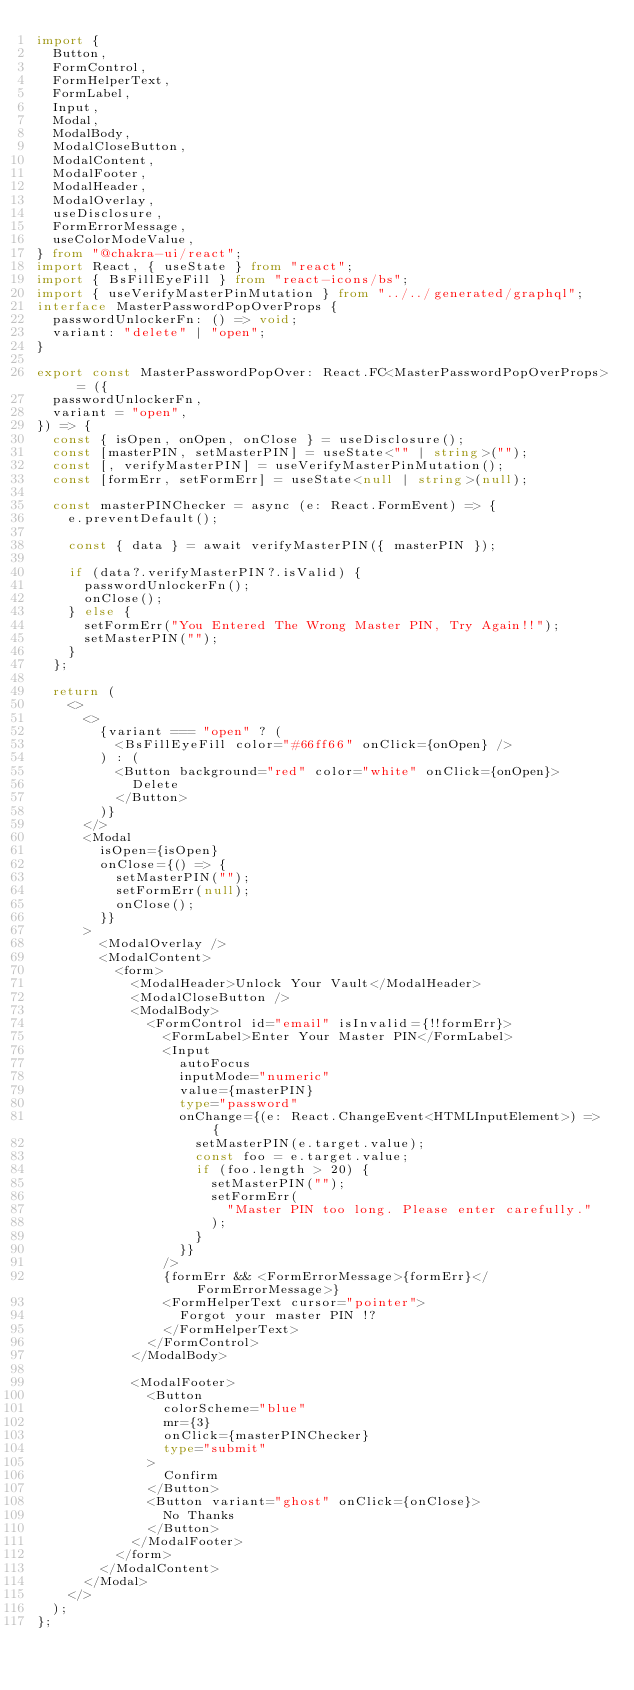Convert code to text. <code><loc_0><loc_0><loc_500><loc_500><_TypeScript_>import {
  Button,
  FormControl,
  FormHelperText,
  FormLabel,
  Input,
  Modal,
  ModalBody,
  ModalCloseButton,
  ModalContent,
  ModalFooter,
  ModalHeader,
  ModalOverlay,
  useDisclosure,
  FormErrorMessage,
  useColorModeValue,
} from "@chakra-ui/react";
import React, { useState } from "react";
import { BsFillEyeFill } from "react-icons/bs";
import { useVerifyMasterPinMutation } from "../../generated/graphql";
interface MasterPasswordPopOverProps {
  passwordUnlockerFn: () => void;
  variant: "delete" | "open";
}

export const MasterPasswordPopOver: React.FC<MasterPasswordPopOverProps> = ({
  passwordUnlockerFn,
  variant = "open",
}) => {
  const { isOpen, onOpen, onClose } = useDisclosure();
  const [masterPIN, setMasterPIN] = useState<"" | string>("");
  const [, verifyMasterPIN] = useVerifyMasterPinMutation();
  const [formErr, setFormErr] = useState<null | string>(null);

  const masterPINChecker = async (e: React.FormEvent) => {
    e.preventDefault();

    const { data } = await verifyMasterPIN({ masterPIN });

    if (data?.verifyMasterPIN?.isValid) {
      passwordUnlockerFn();
      onClose();
    } else {
      setFormErr("You Entered The Wrong Master PIN, Try Again!!");
      setMasterPIN("");
    }
  };

  return (
    <>
      <>
        {variant === "open" ? (
          <BsFillEyeFill color="#66ff66" onClick={onOpen} />
        ) : (
          <Button background="red" color="white" onClick={onOpen}>
            Delete
          </Button>
        )}
      </>
      <Modal
        isOpen={isOpen}
        onClose={() => {
          setMasterPIN("");
          setFormErr(null);
          onClose();
        }}
      >
        <ModalOverlay />
        <ModalContent>
          <form>
            <ModalHeader>Unlock Your Vault</ModalHeader>
            <ModalCloseButton />
            <ModalBody>
              <FormControl id="email" isInvalid={!!formErr}>
                <FormLabel>Enter Your Master PIN</FormLabel>
                <Input
                  autoFocus
                  inputMode="numeric"
                  value={masterPIN}
                  type="password"
                  onChange={(e: React.ChangeEvent<HTMLInputElement>) => {
                    setMasterPIN(e.target.value);
                    const foo = e.target.value;
                    if (foo.length > 20) {
                      setMasterPIN("");
                      setFormErr(
                        "Master PIN too long. Please enter carefully."
                      );
                    }
                  }}
                />
                {formErr && <FormErrorMessage>{formErr}</FormErrorMessage>}
                <FormHelperText cursor="pointer">
                  Forgot your master PIN !?
                </FormHelperText>
              </FormControl>
            </ModalBody>

            <ModalFooter>
              <Button
                colorScheme="blue"
                mr={3}
                onClick={masterPINChecker}
                type="submit"
              >
                Confirm
              </Button>
              <Button variant="ghost" onClick={onClose}>
                No Thanks
              </Button>
            </ModalFooter>
          </form>
        </ModalContent>
      </Modal>
    </>
  );
};
</code> 